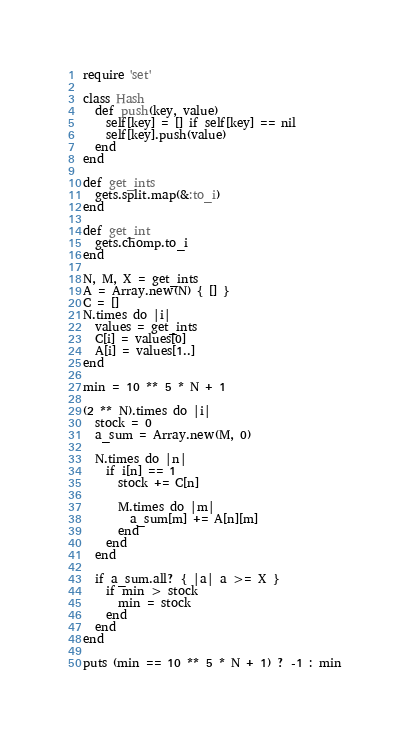<code> <loc_0><loc_0><loc_500><loc_500><_Ruby_>require 'set'

class Hash
  def push(key, value)
    self[key] = [] if self[key] == nil
    self[key].push(value)
  end
end

def get_ints
  gets.split.map(&:to_i)
end

def get_int
  gets.chomp.to_i
end

N, M, X = get_ints
A = Array.new(N) { [] }
C = []
N.times do |i|
  values = get_ints
  C[i] = values[0]
  A[i] = values[1..]
end

min = 10 ** 5 * N + 1

(2 ** N).times do |i|
  stock = 0
  a_sum = Array.new(M, 0)

  N.times do |n|
    if i[n] == 1
      stock += C[n]

      M.times do |m|
        a_sum[m] += A[n][m]
      end
    end
  end

  if a_sum.all? { |a| a >= X }
    if min > stock
      min = stock
    end
  end
end

puts (min == 10 ** 5 * N + 1) ? -1 : min
</code> 